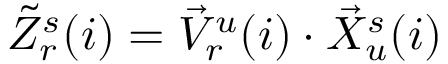<formula> <loc_0><loc_0><loc_500><loc_500>\begin{array} { r } { \tilde { Z } _ { r } ^ { s } ( i ) = \vec { V } _ { r } ^ { u } ( i ) \cdot \vec { X } _ { u } ^ { s } ( i ) } \end{array}</formula> 